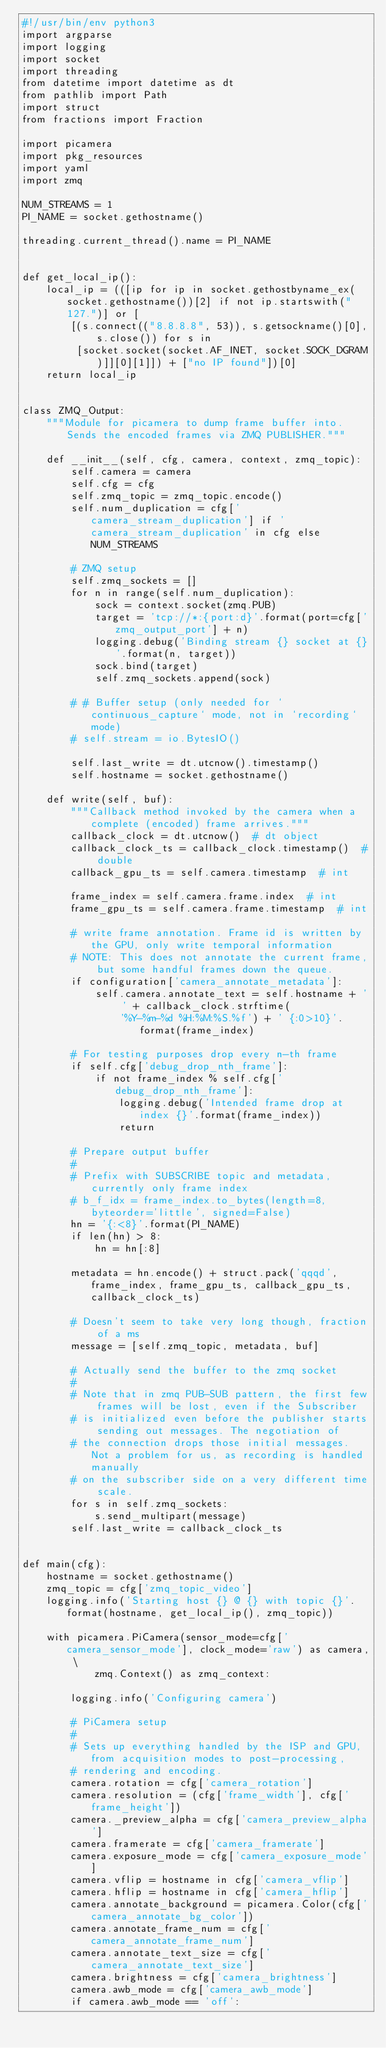<code> <loc_0><loc_0><loc_500><loc_500><_Python_>#!/usr/bin/env python3
import argparse
import logging
import socket
import threading
from datetime import datetime as dt
from pathlib import Path
import struct
from fractions import Fraction

import picamera
import pkg_resources
import yaml
import zmq

NUM_STREAMS = 1
PI_NAME = socket.gethostname()

threading.current_thread().name = PI_NAME


def get_local_ip():
    local_ip = (([ip for ip in socket.gethostbyname_ex(socket.gethostname())[2] if not ip.startswith("127.")] or [
        [(s.connect(("8.8.8.8", 53)), s.getsockname()[0], s.close()) for s in
         [socket.socket(socket.AF_INET, socket.SOCK_DGRAM)]][0][1]]) + ["no IP found"])[0]
    return local_ip


class ZMQ_Output:
    """Module for picamera to dump frame buffer into. Sends the encoded frames via ZMQ PUBLISHER."""

    def __init__(self, cfg, camera, context, zmq_topic):
        self.camera = camera
        self.cfg = cfg
        self.zmq_topic = zmq_topic.encode()
        self.num_duplication = cfg['camera_stream_duplication'] if 'camera_stream_duplication' in cfg else NUM_STREAMS

        # ZMQ setup
        self.zmq_sockets = []
        for n in range(self.num_duplication):
            sock = context.socket(zmq.PUB)
            target = 'tcp://*:{port:d}'.format(port=cfg['zmq_output_port'] + n)
            logging.debug('Binding stream {} socket at {}'.format(n, target))
            sock.bind(target)
            self.zmq_sockets.append(sock)

        # # Buffer setup (only needed for `continuous_capture` mode, not in `recording` mode)
        # self.stream = io.BytesIO()

        self.last_write = dt.utcnow().timestamp()
        self.hostname = socket.gethostname()

    def write(self, buf):
        """Callback method invoked by the camera when a complete (encoded) frame arrives."""
        callback_clock = dt.utcnow()  # dt object
        callback_clock_ts = callback_clock.timestamp()  # double
        callback_gpu_ts = self.camera.timestamp  # int

        frame_index = self.camera.frame.index  # int
        frame_gpu_ts = self.camera.frame.timestamp  # int

        # write frame annotation. Frame id is written by the GPU, only write temporal information
        # NOTE: This does not annotate the current frame, but some handful frames down the queue.
        if configuration['camera_annotate_metadata']:
            self.camera.annotate_text = self.hostname + ' ' + callback_clock.strftime(
                '%Y-%m-%d %H:%M:%S.%f') + ' {:0>10}'.format(frame_index)

        # For testing purposes drop every n-th frame
        if self.cfg['debug_drop_nth_frame']:
            if not frame_index % self.cfg['debug_drop_nth_frame']:
                logging.debug('Intended frame drop at index {}'.format(frame_index))
                return

        # Prepare output buffer
        #
        # Prefix with SUBSCRIBE topic and metadata, currently only frame index
        # b_f_idx = frame_index.to_bytes(length=8, byteorder='little', signed=False)
        hn = '{:<8}'.format(PI_NAME)
        if len(hn) > 8:
            hn = hn[:8]

        metadata = hn.encode() + struct.pack('qqqd', frame_index, frame_gpu_ts, callback_gpu_ts, callback_clock_ts)

        # Doesn't seem to take very long though, fraction of a ms
        message = [self.zmq_topic, metadata, buf]

        # Actually send the buffer to the zmq socket
        #
        # Note that in zmq PUB-SUB pattern, the first few frames will be lost, even if the Subscriber
        # is initialized even before the publisher starts sending out messages. The negotiation of
        # the connection drops those initial messages. Not a problem for us, as recording is handled manually
        # on the subscriber side on a very different time scale.
        for s in self.zmq_sockets:
            s.send_multipart(message)
        self.last_write = callback_clock_ts


def main(cfg):
    hostname = socket.gethostname()
    zmq_topic = cfg['zmq_topic_video']
    logging.info('Starting host {} @ {} with topic {}'.format(hostname, get_local_ip(), zmq_topic))

    with picamera.PiCamera(sensor_mode=cfg['camera_sensor_mode'], clock_mode='raw') as camera, \
            zmq.Context() as zmq_context:

        logging.info('Configuring camera')

        # PiCamera setup
        #
        # Sets up everything handled by the ISP and GPU, from acquisition modes to post-processing,
        # rendering and encoding.
        camera.rotation = cfg['camera_rotation']
        camera.resolution = (cfg['frame_width'], cfg['frame_height'])
        camera._preview_alpha = cfg['camera_preview_alpha']
        camera.framerate = cfg['camera_framerate']
        camera.exposure_mode = cfg['camera_exposure_mode']
        camera.vflip = hostname in cfg['camera_vflip']
        camera.hflip = hostname in cfg['camera_hflip']
        camera.annotate_background = picamera.Color(cfg['camera_annotate_bg_color'])
        camera.annotate_frame_num = cfg['camera_annotate_frame_num']
        camera.annotate_text_size = cfg['camera_annotate_text_size']
        camera.brightness = cfg['camera_brightness']
        camera.awb_mode = cfg['camera_awb_mode']
        if camera.awb_mode == 'off':</code> 